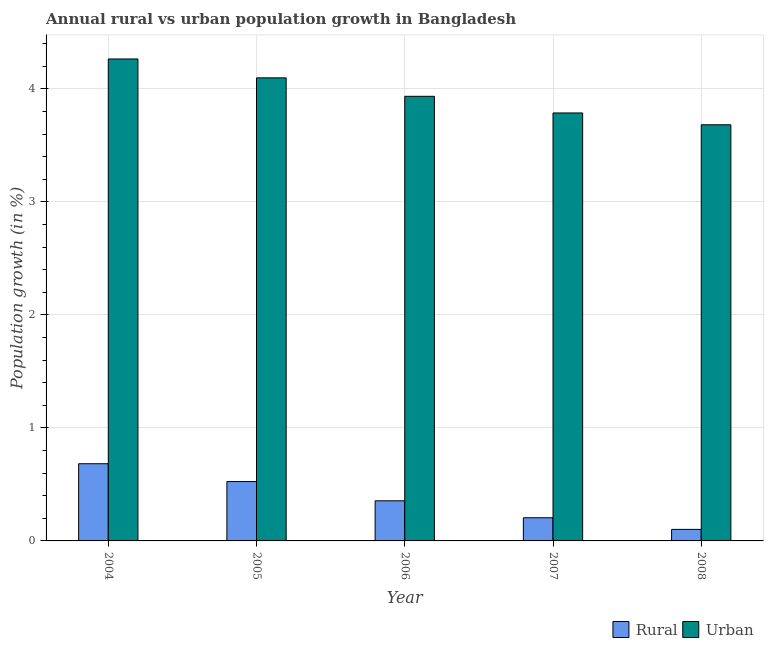How many different coloured bars are there?
Your response must be concise. 2. Are the number of bars per tick equal to the number of legend labels?
Offer a terse response. Yes. How many bars are there on the 5th tick from the left?
Provide a short and direct response. 2. How many bars are there on the 1st tick from the right?
Your response must be concise. 2. What is the urban population growth in 2006?
Make the answer very short. 3.93. Across all years, what is the maximum rural population growth?
Offer a very short reply. 0.68. Across all years, what is the minimum rural population growth?
Ensure brevity in your answer.  0.1. In which year was the urban population growth minimum?
Provide a short and direct response. 2008. What is the total urban population growth in the graph?
Provide a succinct answer. 19.76. What is the difference between the rural population growth in 2006 and that in 2008?
Provide a succinct answer. 0.25. What is the difference between the urban population growth in 2008 and the rural population growth in 2007?
Ensure brevity in your answer.  -0.1. What is the average rural population growth per year?
Offer a very short reply. 0.37. In the year 2005, what is the difference between the rural population growth and urban population growth?
Keep it short and to the point. 0. What is the ratio of the rural population growth in 2006 to that in 2007?
Provide a short and direct response. 1.73. Is the urban population growth in 2006 less than that in 2007?
Your response must be concise. No. What is the difference between the highest and the second highest urban population growth?
Provide a succinct answer. 0.17. What is the difference between the highest and the lowest rural population growth?
Make the answer very short. 0.58. In how many years, is the rural population growth greater than the average rural population growth taken over all years?
Offer a very short reply. 2. What does the 1st bar from the left in 2006 represents?
Your answer should be compact. Rural. What does the 1st bar from the right in 2007 represents?
Offer a terse response. Urban . Where does the legend appear in the graph?
Make the answer very short. Bottom right. How many legend labels are there?
Keep it short and to the point. 2. How are the legend labels stacked?
Provide a succinct answer. Horizontal. What is the title of the graph?
Provide a succinct answer. Annual rural vs urban population growth in Bangladesh. What is the label or title of the X-axis?
Provide a succinct answer. Year. What is the label or title of the Y-axis?
Offer a terse response. Population growth (in %). What is the Population growth (in %) of Rural in 2004?
Provide a succinct answer. 0.68. What is the Population growth (in %) in Urban  in 2004?
Your answer should be compact. 4.26. What is the Population growth (in %) of Rural in 2005?
Offer a terse response. 0.53. What is the Population growth (in %) of Urban  in 2005?
Provide a short and direct response. 4.1. What is the Population growth (in %) in Rural in 2006?
Provide a short and direct response. 0.35. What is the Population growth (in %) of Urban  in 2006?
Offer a very short reply. 3.93. What is the Population growth (in %) in Rural in 2007?
Offer a very short reply. 0.21. What is the Population growth (in %) of Urban  in 2007?
Offer a very short reply. 3.79. What is the Population growth (in %) in Rural in 2008?
Offer a terse response. 0.1. What is the Population growth (in %) in Urban  in 2008?
Give a very brief answer. 3.68. Across all years, what is the maximum Population growth (in %) in Rural?
Your answer should be compact. 0.68. Across all years, what is the maximum Population growth (in %) in Urban ?
Provide a short and direct response. 4.26. Across all years, what is the minimum Population growth (in %) of Rural?
Your answer should be compact. 0.1. Across all years, what is the minimum Population growth (in %) of Urban ?
Give a very brief answer. 3.68. What is the total Population growth (in %) in Rural in the graph?
Offer a very short reply. 1.87. What is the total Population growth (in %) in Urban  in the graph?
Your answer should be very brief. 19.76. What is the difference between the Population growth (in %) in Rural in 2004 and that in 2005?
Keep it short and to the point. 0.16. What is the difference between the Population growth (in %) of Urban  in 2004 and that in 2005?
Your answer should be compact. 0.17. What is the difference between the Population growth (in %) of Rural in 2004 and that in 2006?
Provide a short and direct response. 0.33. What is the difference between the Population growth (in %) of Urban  in 2004 and that in 2006?
Offer a terse response. 0.33. What is the difference between the Population growth (in %) in Rural in 2004 and that in 2007?
Give a very brief answer. 0.48. What is the difference between the Population growth (in %) of Urban  in 2004 and that in 2007?
Your response must be concise. 0.48. What is the difference between the Population growth (in %) of Rural in 2004 and that in 2008?
Offer a very short reply. 0.58. What is the difference between the Population growth (in %) of Urban  in 2004 and that in 2008?
Offer a very short reply. 0.58. What is the difference between the Population growth (in %) in Rural in 2005 and that in 2006?
Give a very brief answer. 0.17. What is the difference between the Population growth (in %) of Urban  in 2005 and that in 2006?
Offer a very short reply. 0.16. What is the difference between the Population growth (in %) of Rural in 2005 and that in 2007?
Keep it short and to the point. 0.32. What is the difference between the Population growth (in %) in Urban  in 2005 and that in 2007?
Give a very brief answer. 0.31. What is the difference between the Population growth (in %) of Rural in 2005 and that in 2008?
Give a very brief answer. 0.42. What is the difference between the Population growth (in %) in Urban  in 2005 and that in 2008?
Ensure brevity in your answer.  0.42. What is the difference between the Population growth (in %) in Rural in 2006 and that in 2007?
Provide a short and direct response. 0.15. What is the difference between the Population growth (in %) of Urban  in 2006 and that in 2007?
Keep it short and to the point. 0.15. What is the difference between the Population growth (in %) in Rural in 2006 and that in 2008?
Provide a short and direct response. 0.25. What is the difference between the Population growth (in %) in Urban  in 2006 and that in 2008?
Provide a short and direct response. 0.25. What is the difference between the Population growth (in %) of Rural in 2007 and that in 2008?
Your answer should be very brief. 0.1. What is the difference between the Population growth (in %) of Urban  in 2007 and that in 2008?
Your answer should be compact. 0.1. What is the difference between the Population growth (in %) in Rural in 2004 and the Population growth (in %) in Urban  in 2005?
Your response must be concise. -3.41. What is the difference between the Population growth (in %) of Rural in 2004 and the Population growth (in %) of Urban  in 2006?
Your answer should be compact. -3.25. What is the difference between the Population growth (in %) of Rural in 2004 and the Population growth (in %) of Urban  in 2007?
Provide a succinct answer. -3.1. What is the difference between the Population growth (in %) of Rural in 2004 and the Population growth (in %) of Urban  in 2008?
Give a very brief answer. -3. What is the difference between the Population growth (in %) of Rural in 2005 and the Population growth (in %) of Urban  in 2006?
Give a very brief answer. -3.41. What is the difference between the Population growth (in %) in Rural in 2005 and the Population growth (in %) in Urban  in 2007?
Make the answer very short. -3.26. What is the difference between the Population growth (in %) of Rural in 2005 and the Population growth (in %) of Urban  in 2008?
Offer a very short reply. -3.16. What is the difference between the Population growth (in %) of Rural in 2006 and the Population growth (in %) of Urban  in 2007?
Keep it short and to the point. -3.43. What is the difference between the Population growth (in %) in Rural in 2006 and the Population growth (in %) in Urban  in 2008?
Your response must be concise. -3.33. What is the difference between the Population growth (in %) in Rural in 2007 and the Population growth (in %) in Urban  in 2008?
Give a very brief answer. -3.48. What is the average Population growth (in %) in Rural per year?
Give a very brief answer. 0.37. What is the average Population growth (in %) of Urban  per year?
Give a very brief answer. 3.95. In the year 2004, what is the difference between the Population growth (in %) in Rural and Population growth (in %) in Urban ?
Give a very brief answer. -3.58. In the year 2005, what is the difference between the Population growth (in %) of Rural and Population growth (in %) of Urban ?
Provide a succinct answer. -3.57. In the year 2006, what is the difference between the Population growth (in %) of Rural and Population growth (in %) of Urban ?
Offer a terse response. -3.58. In the year 2007, what is the difference between the Population growth (in %) of Rural and Population growth (in %) of Urban ?
Provide a short and direct response. -3.58. In the year 2008, what is the difference between the Population growth (in %) of Rural and Population growth (in %) of Urban ?
Provide a short and direct response. -3.58. What is the ratio of the Population growth (in %) in Rural in 2004 to that in 2005?
Provide a succinct answer. 1.3. What is the ratio of the Population growth (in %) in Urban  in 2004 to that in 2005?
Make the answer very short. 1.04. What is the ratio of the Population growth (in %) in Rural in 2004 to that in 2006?
Keep it short and to the point. 1.92. What is the ratio of the Population growth (in %) in Urban  in 2004 to that in 2006?
Provide a succinct answer. 1.08. What is the ratio of the Population growth (in %) in Rural in 2004 to that in 2007?
Offer a very short reply. 3.33. What is the ratio of the Population growth (in %) of Urban  in 2004 to that in 2007?
Provide a short and direct response. 1.13. What is the ratio of the Population growth (in %) of Rural in 2004 to that in 2008?
Provide a succinct answer. 6.69. What is the ratio of the Population growth (in %) of Urban  in 2004 to that in 2008?
Provide a short and direct response. 1.16. What is the ratio of the Population growth (in %) in Rural in 2005 to that in 2006?
Offer a very short reply. 1.48. What is the ratio of the Population growth (in %) in Urban  in 2005 to that in 2006?
Your response must be concise. 1.04. What is the ratio of the Population growth (in %) in Rural in 2005 to that in 2007?
Ensure brevity in your answer.  2.56. What is the ratio of the Population growth (in %) of Urban  in 2005 to that in 2007?
Offer a very short reply. 1.08. What is the ratio of the Population growth (in %) in Rural in 2005 to that in 2008?
Give a very brief answer. 5.15. What is the ratio of the Population growth (in %) in Urban  in 2005 to that in 2008?
Make the answer very short. 1.11. What is the ratio of the Population growth (in %) in Rural in 2006 to that in 2007?
Make the answer very short. 1.73. What is the ratio of the Population growth (in %) of Urban  in 2006 to that in 2007?
Offer a very short reply. 1.04. What is the ratio of the Population growth (in %) in Rural in 2006 to that in 2008?
Provide a short and direct response. 3.48. What is the ratio of the Population growth (in %) of Urban  in 2006 to that in 2008?
Your response must be concise. 1.07. What is the ratio of the Population growth (in %) in Rural in 2007 to that in 2008?
Your response must be concise. 2.01. What is the ratio of the Population growth (in %) of Urban  in 2007 to that in 2008?
Keep it short and to the point. 1.03. What is the difference between the highest and the second highest Population growth (in %) of Rural?
Keep it short and to the point. 0.16. What is the difference between the highest and the second highest Population growth (in %) in Urban ?
Your answer should be compact. 0.17. What is the difference between the highest and the lowest Population growth (in %) of Rural?
Provide a succinct answer. 0.58. What is the difference between the highest and the lowest Population growth (in %) in Urban ?
Give a very brief answer. 0.58. 